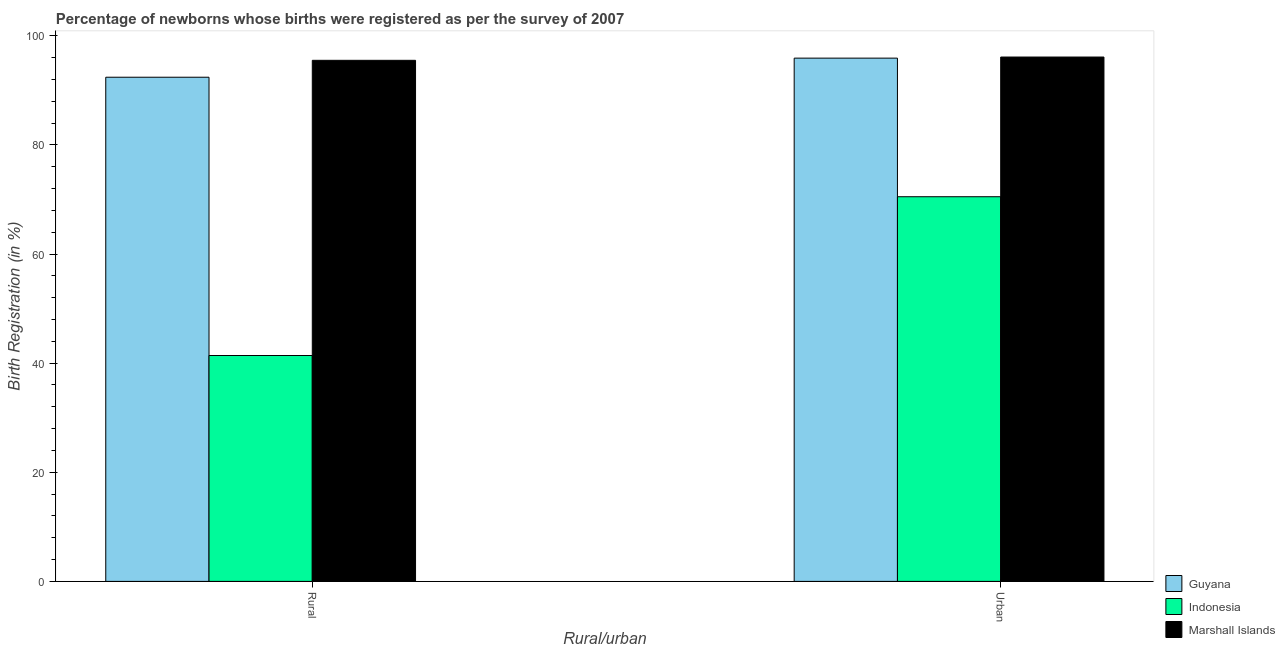Are the number of bars per tick equal to the number of legend labels?
Give a very brief answer. Yes. Are the number of bars on each tick of the X-axis equal?
Provide a succinct answer. Yes. How many bars are there on the 2nd tick from the left?
Keep it short and to the point. 3. What is the label of the 1st group of bars from the left?
Provide a succinct answer. Rural. What is the rural birth registration in Guyana?
Provide a short and direct response. 92.4. Across all countries, what is the maximum urban birth registration?
Offer a very short reply. 96.1. Across all countries, what is the minimum urban birth registration?
Provide a short and direct response. 70.5. In which country was the rural birth registration maximum?
Give a very brief answer. Marshall Islands. What is the total rural birth registration in the graph?
Provide a short and direct response. 229.3. What is the difference between the rural birth registration in Guyana and that in Marshall Islands?
Ensure brevity in your answer.  -3.1. What is the difference between the urban birth registration in Indonesia and the rural birth registration in Guyana?
Your answer should be compact. -21.9. What is the average rural birth registration per country?
Offer a terse response. 76.43. What is the difference between the rural birth registration and urban birth registration in Indonesia?
Keep it short and to the point. -29.1. In how many countries, is the urban birth registration greater than 84 %?
Make the answer very short. 2. What is the ratio of the rural birth registration in Indonesia to that in Marshall Islands?
Provide a succinct answer. 0.43. What does the 1st bar from the right in Rural represents?
Make the answer very short. Marshall Islands. Are all the bars in the graph horizontal?
Your answer should be compact. No. How many countries are there in the graph?
Provide a succinct answer. 3. What is the difference between two consecutive major ticks on the Y-axis?
Give a very brief answer. 20. Does the graph contain any zero values?
Give a very brief answer. No. How are the legend labels stacked?
Your answer should be very brief. Vertical. What is the title of the graph?
Provide a succinct answer. Percentage of newborns whose births were registered as per the survey of 2007. What is the label or title of the X-axis?
Your answer should be very brief. Rural/urban. What is the label or title of the Y-axis?
Provide a succinct answer. Birth Registration (in %). What is the Birth Registration (in %) of Guyana in Rural?
Provide a short and direct response. 92.4. What is the Birth Registration (in %) of Indonesia in Rural?
Give a very brief answer. 41.4. What is the Birth Registration (in %) in Marshall Islands in Rural?
Your answer should be very brief. 95.5. What is the Birth Registration (in %) in Guyana in Urban?
Give a very brief answer. 95.9. What is the Birth Registration (in %) in Indonesia in Urban?
Ensure brevity in your answer.  70.5. What is the Birth Registration (in %) in Marshall Islands in Urban?
Offer a terse response. 96.1. Across all Rural/urban, what is the maximum Birth Registration (in %) of Guyana?
Offer a very short reply. 95.9. Across all Rural/urban, what is the maximum Birth Registration (in %) in Indonesia?
Make the answer very short. 70.5. Across all Rural/urban, what is the maximum Birth Registration (in %) of Marshall Islands?
Your answer should be compact. 96.1. Across all Rural/urban, what is the minimum Birth Registration (in %) of Guyana?
Make the answer very short. 92.4. Across all Rural/urban, what is the minimum Birth Registration (in %) of Indonesia?
Provide a succinct answer. 41.4. Across all Rural/urban, what is the minimum Birth Registration (in %) in Marshall Islands?
Make the answer very short. 95.5. What is the total Birth Registration (in %) in Guyana in the graph?
Provide a succinct answer. 188.3. What is the total Birth Registration (in %) of Indonesia in the graph?
Your answer should be very brief. 111.9. What is the total Birth Registration (in %) of Marshall Islands in the graph?
Ensure brevity in your answer.  191.6. What is the difference between the Birth Registration (in %) in Indonesia in Rural and that in Urban?
Make the answer very short. -29.1. What is the difference between the Birth Registration (in %) in Marshall Islands in Rural and that in Urban?
Ensure brevity in your answer.  -0.6. What is the difference between the Birth Registration (in %) of Guyana in Rural and the Birth Registration (in %) of Indonesia in Urban?
Ensure brevity in your answer.  21.9. What is the difference between the Birth Registration (in %) of Indonesia in Rural and the Birth Registration (in %) of Marshall Islands in Urban?
Ensure brevity in your answer.  -54.7. What is the average Birth Registration (in %) of Guyana per Rural/urban?
Give a very brief answer. 94.15. What is the average Birth Registration (in %) of Indonesia per Rural/urban?
Your answer should be very brief. 55.95. What is the average Birth Registration (in %) in Marshall Islands per Rural/urban?
Provide a short and direct response. 95.8. What is the difference between the Birth Registration (in %) in Indonesia and Birth Registration (in %) in Marshall Islands in Rural?
Ensure brevity in your answer.  -54.1. What is the difference between the Birth Registration (in %) of Guyana and Birth Registration (in %) of Indonesia in Urban?
Your response must be concise. 25.4. What is the difference between the Birth Registration (in %) of Guyana and Birth Registration (in %) of Marshall Islands in Urban?
Your response must be concise. -0.2. What is the difference between the Birth Registration (in %) of Indonesia and Birth Registration (in %) of Marshall Islands in Urban?
Give a very brief answer. -25.6. What is the ratio of the Birth Registration (in %) in Guyana in Rural to that in Urban?
Give a very brief answer. 0.96. What is the ratio of the Birth Registration (in %) of Indonesia in Rural to that in Urban?
Your answer should be very brief. 0.59. What is the ratio of the Birth Registration (in %) of Marshall Islands in Rural to that in Urban?
Offer a terse response. 0.99. What is the difference between the highest and the second highest Birth Registration (in %) in Guyana?
Provide a short and direct response. 3.5. What is the difference between the highest and the second highest Birth Registration (in %) in Indonesia?
Ensure brevity in your answer.  29.1. What is the difference between the highest and the lowest Birth Registration (in %) of Guyana?
Your answer should be compact. 3.5. What is the difference between the highest and the lowest Birth Registration (in %) in Indonesia?
Your answer should be compact. 29.1. 